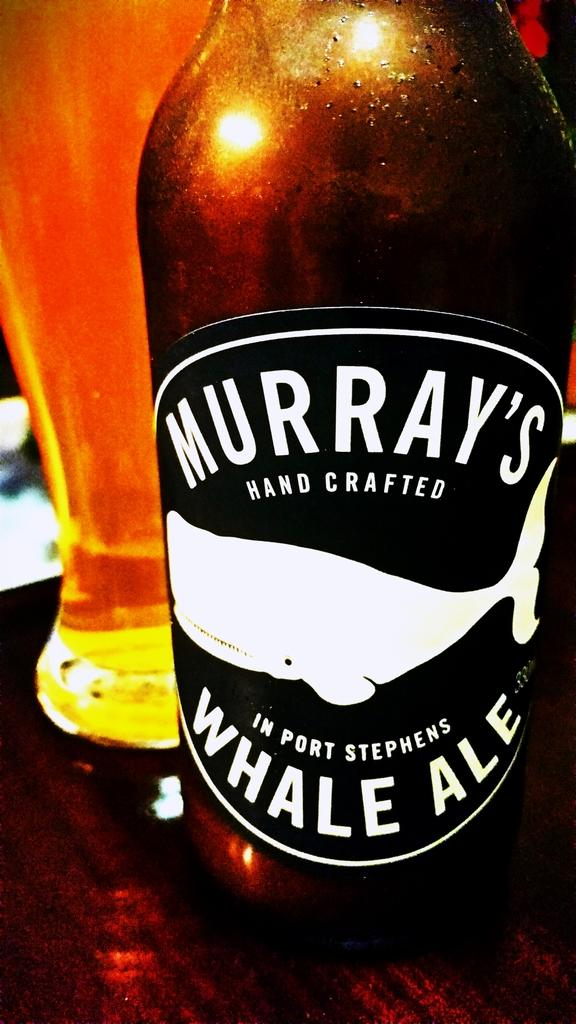<image>
Present a compact description of the photo's key features. A bottle of Murray's hand crafted ale is on the table. 